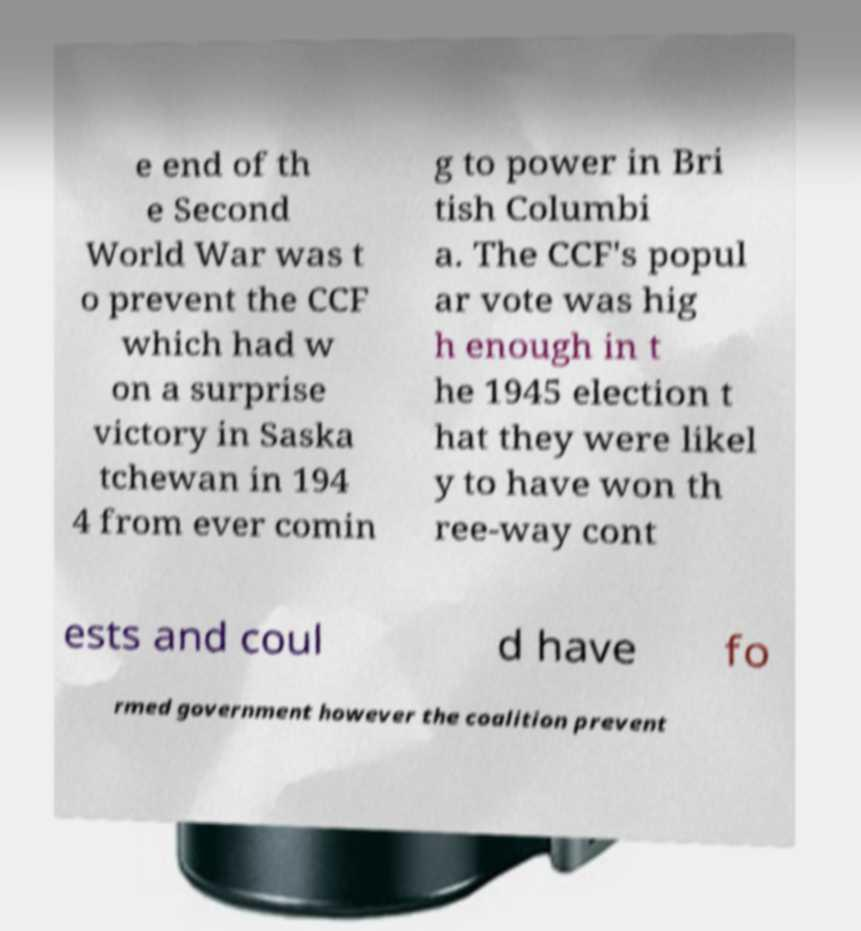Could you assist in decoding the text presented in this image and type it out clearly? e end of th e Second World War was t o prevent the CCF which had w on a surprise victory in Saska tchewan in 194 4 from ever comin g to power in Bri tish Columbi a. The CCF's popul ar vote was hig h enough in t he 1945 election t hat they were likel y to have won th ree-way cont ests and coul d have fo rmed government however the coalition prevent 